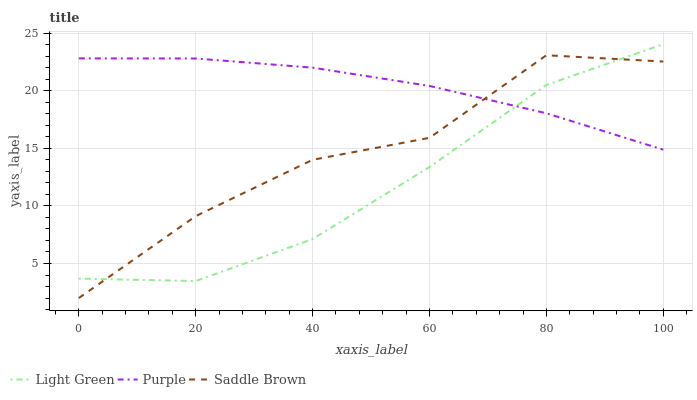Does Light Green have the minimum area under the curve?
Answer yes or no. Yes. Does Purple have the maximum area under the curve?
Answer yes or no. Yes. Does Saddle Brown have the minimum area under the curve?
Answer yes or no. No. Does Saddle Brown have the maximum area under the curve?
Answer yes or no. No. Is Purple the smoothest?
Answer yes or no. Yes. Is Saddle Brown the roughest?
Answer yes or no. Yes. Is Light Green the smoothest?
Answer yes or no. No. Is Light Green the roughest?
Answer yes or no. No. Does Saddle Brown have the lowest value?
Answer yes or no. Yes. Does Light Green have the lowest value?
Answer yes or no. No. Does Light Green have the highest value?
Answer yes or no. Yes. Does Saddle Brown have the highest value?
Answer yes or no. No. Does Saddle Brown intersect Light Green?
Answer yes or no. Yes. Is Saddle Brown less than Light Green?
Answer yes or no. No. Is Saddle Brown greater than Light Green?
Answer yes or no. No. 